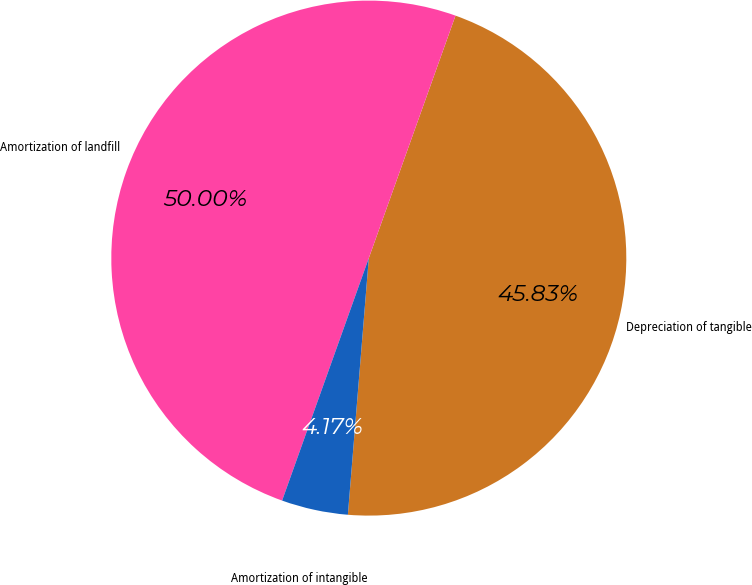Convert chart to OTSL. <chart><loc_0><loc_0><loc_500><loc_500><pie_chart><fcel>Depreciation of tangible<fcel>Amortization of landfill<fcel>Amortization of intangible<nl><fcel>45.83%<fcel>50.0%<fcel>4.17%<nl></chart> 